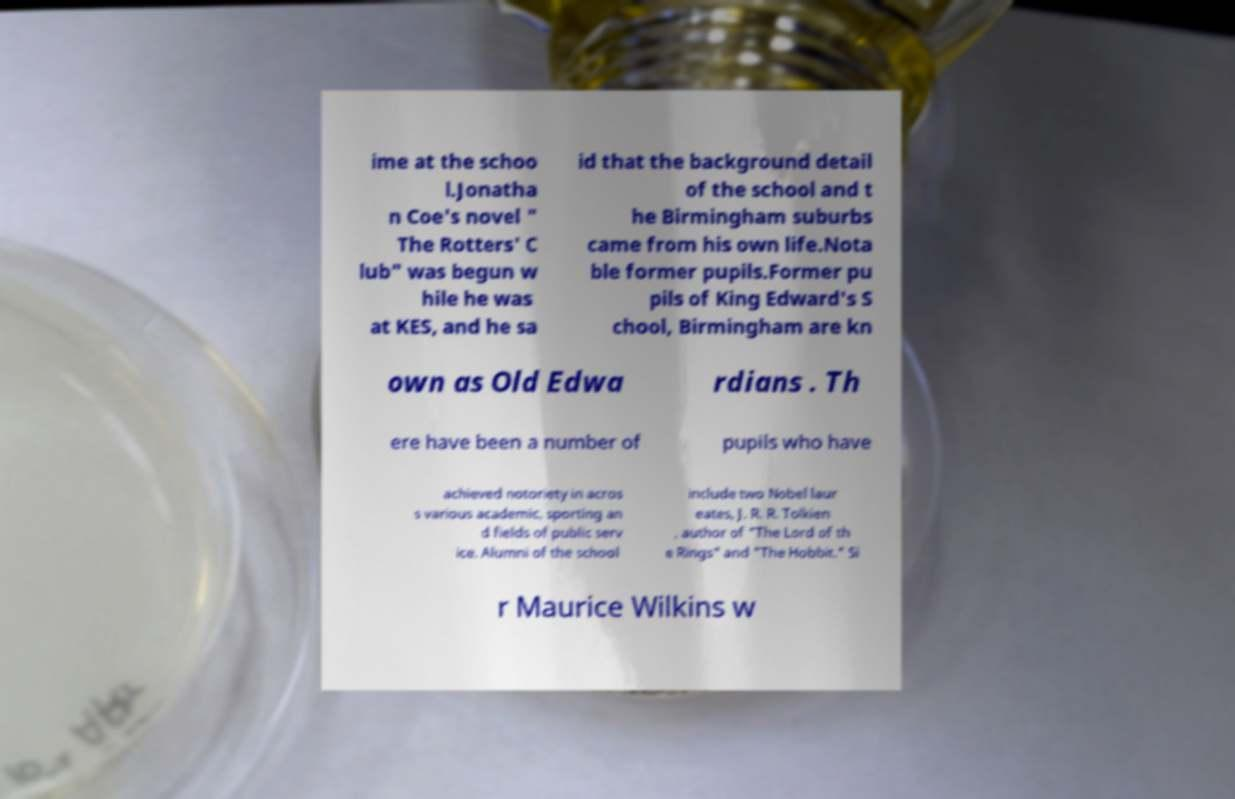Please read and relay the text visible in this image. What does it say? ime at the schoo l.Jonatha n Coe's novel " The Rotters' C lub" was begun w hile he was at KES, and he sa id that the background detail of the school and t he Birmingham suburbs came from his own life.Nota ble former pupils.Former pu pils of King Edward's S chool, Birmingham are kn own as Old Edwa rdians . Th ere have been a number of pupils who have achieved notoriety in acros s various academic, sporting an d fields of public serv ice. Alumni of the school include two Nobel laur eates, J. R. R. Tolkien , author of "The Lord of th e Rings" and "The Hobbit." Si r Maurice Wilkins w 